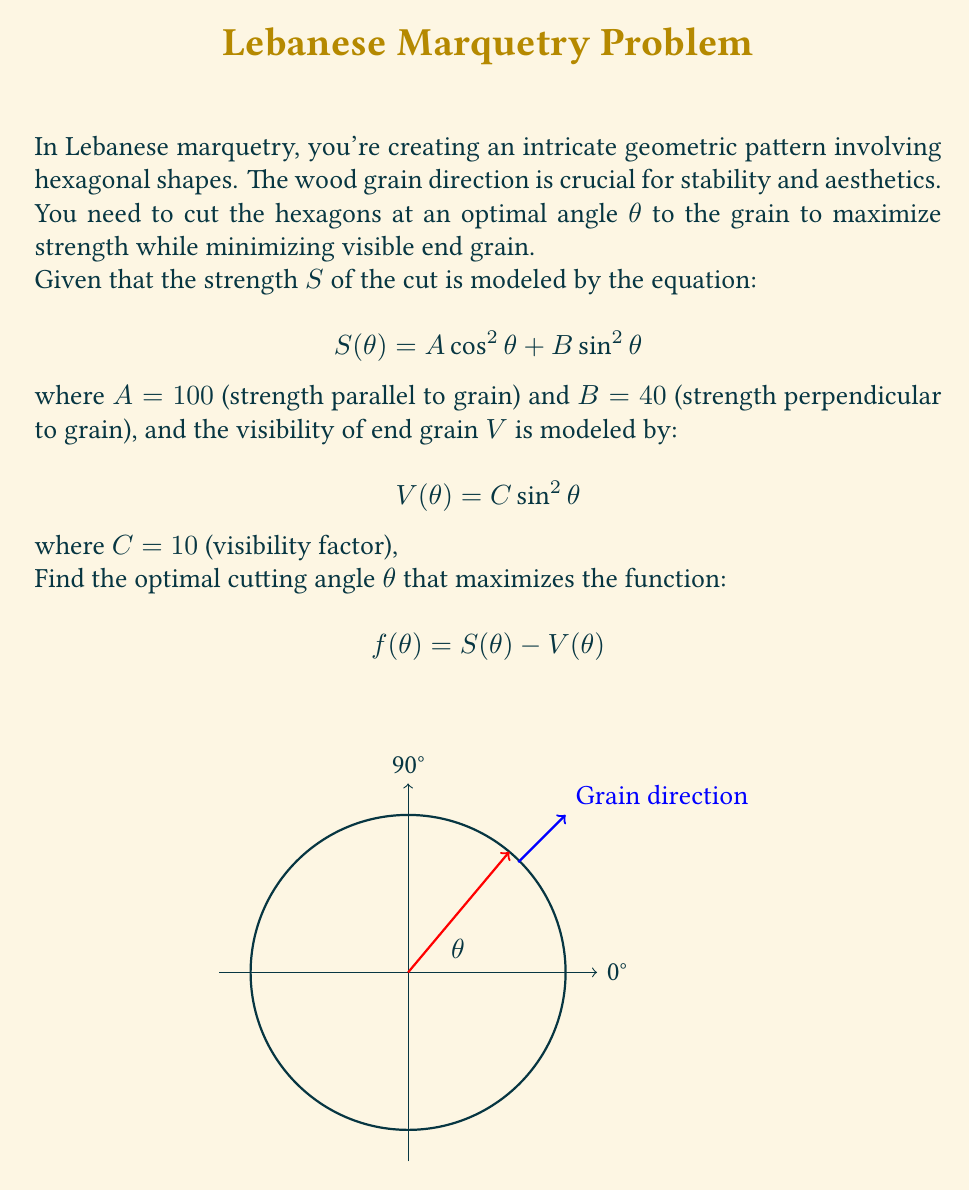Teach me how to tackle this problem. To find the optimal cutting angle, we need to maximize the function f(θ). Let's approach this step-by-step:

1) First, let's expand the function f(θ):

   $$ f(\theta) = S(\theta) - V(\theta) = (A \cos^2\theta + B \sin^2\theta) - C \sin^2\theta $$

2) Substitute the given values:

   $$ f(\theta) = (100 \cos^2\theta + 40 \sin^2\theta) - 10 \sin^2\theta $$

3) Simplify:

   $$ f(\theta) = 100 \cos^2\theta + 30 \sin^2\theta $$

4) To find the maximum, we need to find where the derivative of f(θ) equals zero:

   $$ \frac{df}{d\theta} = -200 \cos\theta \sin\theta + 60 \sin\theta \cos\theta = 0 $$

5) Simplify:

   $$ -140 \sin\theta \cos\theta = 0 $$

6) This equation is satisfied when either sin(θ) = 0 or cos(θ) = 0. However, we're interested in the maximum, not the minimum. The solution cos(θ) = 0 would give us a minimum, so we focus on sin(θ) = 0.

7) sin(θ) = 0 when θ = 0° or 180°. Both of these angles are parallel to the grain, which makes sense as it maximizes strength and minimizes visible end grain.

8) To confirm this is a maximum, we could check the second derivative or evaluate f(θ) at nearby points.

Therefore, the optimal cutting angle is 0° (or equivalently, 180°) to the grain direction.
Answer: 0° 